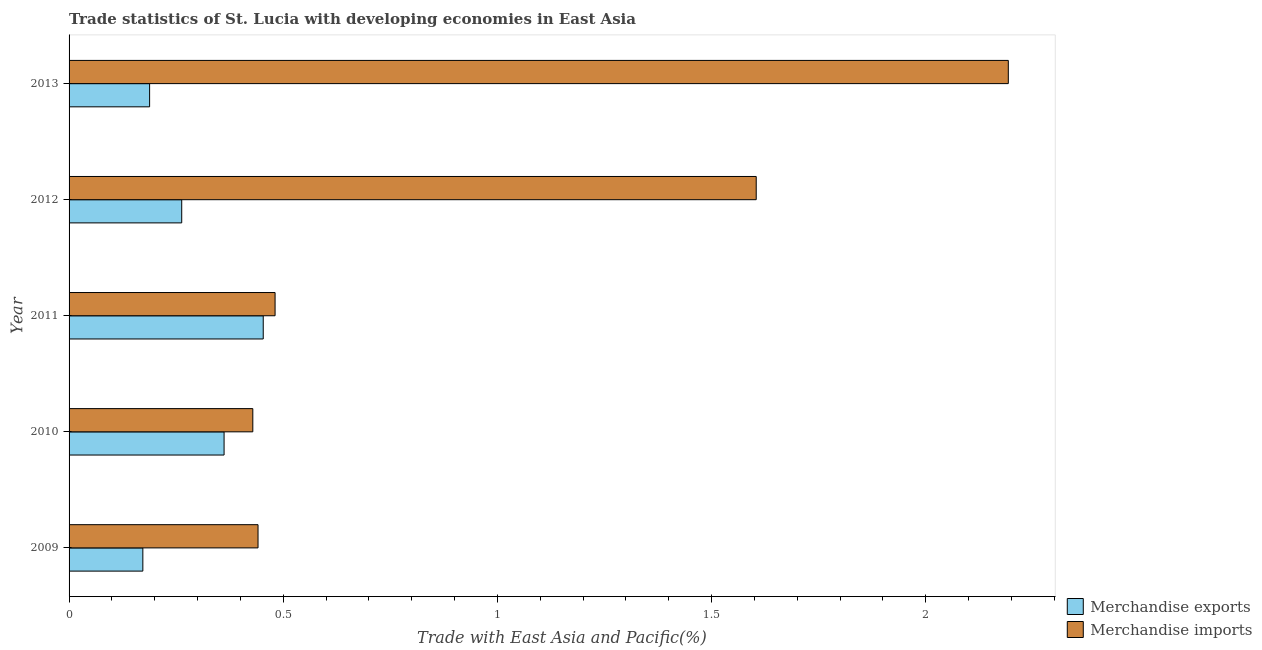How many groups of bars are there?
Give a very brief answer. 5. Are the number of bars per tick equal to the number of legend labels?
Keep it short and to the point. Yes. What is the merchandise imports in 2012?
Give a very brief answer. 1.6. Across all years, what is the maximum merchandise exports?
Offer a very short reply. 0.45. Across all years, what is the minimum merchandise exports?
Your response must be concise. 0.17. What is the total merchandise exports in the graph?
Give a very brief answer. 1.44. What is the difference between the merchandise imports in 2010 and that in 2013?
Your response must be concise. -1.76. What is the difference between the merchandise imports in 2013 and the merchandise exports in 2012?
Your answer should be compact. 1.93. What is the average merchandise imports per year?
Make the answer very short. 1.03. In the year 2009, what is the difference between the merchandise imports and merchandise exports?
Your answer should be compact. 0.27. In how many years, is the merchandise exports greater than 1.9 %?
Make the answer very short. 0. What is the ratio of the merchandise imports in 2010 to that in 2013?
Your answer should be compact. 0.2. Is the merchandise imports in 2012 less than that in 2013?
Provide a short and direct response. Yes. What is the difference between the highest and the second highest merchandise imports?
Your answer should be compact. 0.59. What is the difference between the highest and the lowest merchandise exports?
Your answer should be very brief. 0.28. Is the sum of the merchandise imports in 2010 and 2011 greater than the maximum merchandise exports across all years?
Keep it short and to the point. Yes. What does the 1st bar from the top in 2013 represents?
Ensure brevity in your answer.  Merchandise imports. What does the 2nd bar from the bottom in 2010 represents?
Ensure brevity in your answer.  Merchandise imports. How many bars are there?
Your answer should be very brief. 10. Does the graph contain any zero values?
Offer a very short reply. No. How are the legend labels stacked?
Your answer should be compact. Vertical. What is the title of the graph?
Give a very brief answer. Trade statistics of St. Lucia with developing economies in East Asia. Does "Working capital" appear as one of the legend labels in the graph?
Your answer should be compact. No. What is the label or title of the X-axis?
Your answer should be very brief. Trade with East Asia and Pacific(%). What is the Trade with East Asia and Pacific(%) in Merchandise exports in 2009?
Give a very brief answer. 0.17. What is the Trade with East Asia and Pacific(%) of Merchandise imports in 2009?
Make the answer very short. 0.44. What is the Trade with East Asia and Pacific(%) in Merchandise exports in 2010?
Your answer should be compact. 0.36. What is the Trade with East Asia and Pacific(%) of Merchandise imports in 2010?
Make the answer very short. 0.43. What is the Trade with East Asia and Pacific(%) in Merchandise exports in 2011?
Make the answer very short. 0.45. What is the Trade with East Asia and Pacific(%) of Merchandise imports in 2011?
Your response must be concise. 0.48. What is the Trade with East Asia and Pacific(%) in Merchandise exports in 2012?
Keep it short and to the point. 0.26. What is the Trade with East Asia and Pacific(%) in Merchandise imports in 2012?
Offer a very short reply. 1.6. What is the Trade with East Asia and Pacific(%) of Merchandise exports in 2013?
Offer a very short reply. 0.19. What is the Trade with East Asia and Pacific(%) of Merchandise imports in 2013?
Ensure brevity in your answer.  2.19. Across all years, what is the maximum Trade with East Asia and Pacific(%) in Merchandise exports?
Provide a short and direct response. 0.45. Across all years, what is the maximum Trade with East Asia and Pacific(%) in Merchandise imports?
Your response must be concise. 2.19. Across all years, what is the minimum Trade with East Asia and Pacific(%) in Merchandise exports?
Offer a very short reply. 0.17. Across all years, what is the minimum Trade with East Asia and Pacific(%) of Merchandise imports?
Your answer should be very brief. 0.43. What is the total Trade with East Asia and Pacific(%) in Merchandise exports in the graph?
Provide a short and direct response. 1.44. What is the total Trade with East Asia and Pacific(%) of Merchandise imports in the graph?
Provide a short and direct response. 5.15. What is the difference between the Trade with East Asia and Pacific(%) in Merchandise exports in 2009 and that in 2010?
Your answer should be very brief. -0.19. What is the difference between the Trade with East Asia and Pacific(%) of Merchandise imports in 2009 and that in 2010?
Offer a very short reply. 0.01. What is the difference between the Trade with East Asia and Pacific(%) in Merchandise exports in 2009 and that in 2011?
Your answer should be very brief. -0.28. What is the difference between the Trade with East Asia and Pacific(%) of Merchandise imports in 2009 and that in 2011?
Keep it short and to the point. -0.04. What is the difference between the Trade with East Asia and Pacific(%) in Merchandise exports in 2009 and that in 2012?
Give a very brief answer. -0.09. What is the difference between the Trade with East Asia and Pacific(%) in Merchandise imports in 2009 and that in 2012?
Offer a terse response. -1.16. What is the difference between the Trade with East Asia and Pacific(%) in Merchandise exports in 2009 and that in 2013?
Provide a short and direct response. -0.02. What is the difference between the Trade with East Asia and Pacific(%) in Merchandise imports in 2009 and that in 2013?
Your response must be concise. -1.75. What is the difference between the Trade with East Asia and Pacific(%) in Merchandise exports in 2010 and that in 2011?
Make the answer very short. -0.09. What is the difference between the Trade with East Asia and Pacific(%) of Merchandise imports in 2010 and that in 2011?
Give a very brief answer. -0.05. What is the difference between the Trade with East Asia and Pacific(%) in Merchandise exports in 2010 and that in 2012?
Offer a terse response. 0.1. What is the difference between the Trade with East Asia and Pacific(%) of Merchandise imports in 2010 and that in 2012?
Give a very brief answer. -1.18. What is the difference between the Trade with East Asia and Pacific(%) of Merchandise exports in 2010 and that in 2013?
Give a very brief answer. 0.17. What is the difference between the Trade with East Asia and Pacific(%) of Merchandise imports in 2010 and that in 2013?
Keep it short and to the point. -1.76. What is the difference between the Trade with East Asia and Pacific(%) of Merchandise exports in 2011 and that in 2012?
Your answer should be very brief. 0.19. What is the difference between the Trade with East Asia and Pacific(%) of Merchandise imports in 2011 and that in 2012?
Give a very brief answer. -1.12. What is the difference between the Trade with East Asia and Pacific(%) in Merchandise exports in 2011 and that in 2013?
Give a very brief answer. 0.27. What is the difference between the Trade with East Asia and Pacific(%) of Merchandise imports in 2011 and that in 2013?
Provide a short and direct response. -1.71. What is the difference between the Trade with East Asia and Pacific(%) of Merchandise exports in 2012 and that in 2013?
Your answer should be compact. 0.07. What is the difference between the Trade with East Asia and Pacific(%) of Merchandise imports in 2012 and that in 2013?
Keep it short and to the point. -0.59. What is the difference between the Trade with East Asia and Pacific(%) of Merchandise exports in 2009 and the Trade with East Asia and Pacific(%) of Merchandise imports in 2010?
Offer a terse response. -0.26. What is the difference between the Trade with East Asia and Pacific(%) of Merchandise exports in 2009 and the Trade with East Asia and Pacific(%) of Merchandise imports in 2011?
Offer a terse response. -0.31. What is the difference between the Trade with East Asia and Pacific(%) in Merchandise exports in 2009 and the Trade with East Asia and Pacific(%) in Merchandise imports in 2012?
Provide a succinct answer. -1.43. What is the difference between the Trade with East Asia and Pacific(%) in Merchandise exports in 2009 and the Trade with East Asia and Pacific(%) in Merchandise imports in 2013?
Give a very brief answer. -2.02. What is the difference between the Trade with East Asia and Pacific(%) of Merchandise exports in 2010 and the Trade with East Asia and Pacific(%) of Merchandise imports in 2011?
Your answer should be compact. -0.12. What is the difference between the Trade with East Asia and Pacific(%) in Merchandise exports in 2010 and the Trade with East Asia and Pacific(%) in Merchandise imports in 2012?
Give a very brief answer. -1.24. What is the difference between the Trade with East Asia and Pacific(%) of Merchandise exports in 2010 and the Trade with East Asia and Pacific(%) of Merchandise imports in 2013?
Your answer should be compact. -1.83. What is the difference between the Trade with East Asia and Pacific(%) of Merchandise exports in 2011 and the Trade with East Asia and Pacific(%) of Merchandise imports in 2012?
Offer a very short reply. -1.15. What is the difference between the Trade with East Asia and Pacific(%) of Merchandise exports in 2011 and the Trade with East Asia and Pacific(%) of Merchandise imports in 2013?
Keep it short and to the point. -1.74. What is the difference between the Trade with East Asia and Pacific(%) in Merchandise exports in 2012 and the Trade with East Asia and Pacific(%) in Merchandise imports in 2013?
Offer a terse response. -1.93. What is the average Trade with East Asia and Pacific(%) in Merchandise exports per year?
Provide a short and direct response. 0.29. What is the average Trade with East Asia and Pacific(%) in Merchandise imports per year?
Your answer should be very brief. 1.03. In the year 2009, what is the difference between the Trade with East Asia and Pacific(%) of Merchandise exports and Trade with East Asia and Pacific(%) of Merchandise imports?
Offer a very short reply. -0.27. In the year 2010, what is the difference between the Trade with East Asia and Pacific(%) of Merchandise exports and Trade with East Asia and Pacific(%) of Merchandise imports?
Provide a short and direct response. -0.07. In the year 2011, what is the difference between the Trade with East Asia and Pacific(%) in Merchandise exports and Trade with East Asia and Pacific(%) in Merchandise imports?
Ensure brevity in your answer.  -0.03. In the year 2012, what is the difference between the Trade with East Asia and Pacific(%) of Merchandise exports and Trade with East Asia and Pacific(%) of Merchandise imports?
Ensure brevity in your answer.  -1.34. In the year 2013, what is the difference between the Trade with East Asia and Pacific(%) of Merchandise exports and Trade with East Asia and Pacific(%) of Merchandise imports?
Offer a terse response. -2. What is the ratio of the Trade with East Asia and Pacific(%) in Merchandise exports in 2009 to that in 2010?
Offer a terse response. 0.48. What is the ratio of the Trade with East Asia and Pacific(%) in Merchandise imports in 2009 to that in 2010?
Your answer should be compact. 1.03. What is the ratio of the Trade with East Asia and Pacific(%) in Merchandise exports in 2009 to that in 2011?
Make the answer very short. 0.38. What is the ratio of the Trade with East Asia and Pacific(%) in Merchandise imports in 2009 to that in 2011?
Your answer should be compact. 0.92. What is the ratio of the Trade with East Asia and Pacific(%) of Merchandise exports in 2009 to that in 2012?
Your response must be concise. 0.65. What is the ratio of the Trade with East Asia and Pacific(%) of Merchandise imports in 2009 to that in 2012?
Ensure brevity in your answer.  0.28. What is the ratio of the Trade with East Asia and Pacific(%) in Merchandise exports in 2009 to that in 2013?
Your answer should be compact. 0.92. What is the ratio of the Trade with East Asia and Pacific(%) of Merchandise imports in 2009 to that in 2013?
Ensure brevity in your answer.  0.2. What is the ratio of the Trade with East Asia and Pacific(%) in Merchandise exports in 2010 to that in 2011?
Your answer should be compact. 0.8. What is the ratio of the Trade with East Asia and Pacific(%) in Merchandise imports in 2010 to that in 2011?
Offer a terse response. 0.89. What is the ratio of the Trade with East Asia and Pacific(%) of Merchandise exports in 2010 to that in 2012?
Your answer should be very brief. 1.38. What is the ratio of the Trade with East Asia and Pacific(%) of Merchandise imports in 2010 to that in 2012?
Offer a very short reply. 0.27. What is the ratio of the Trade with East Asia and Pacific(%) in Merchandise exports in 2010 to that in 2013?
Offer a terse response. 1.92. What is the ratio of the Trade with East Asia and Pacific(%) in Merchandise imports in 2010 to that in 2013?
Provide a succinct answer. 0.2. What is the ratio of the Trade with East Asia and Pacific(%) of Merchandise exports in 2011 to that in 2012?
Offer a terse response. 1.72. What is the ratio of the Trade with East Asia and Pacific(%) of Merchandise imports in 2011 to that in 2012?
Your answer should be compact. 0.3. What is the ratio of the Trade with East Asia and Pacific(%) of Merchandise exports in 2011 to that in 2013?
Offer a terse response. 2.41. What is the ratio of the Trade with East Asia and Pacific(%) of Merchandise imports in 2011 to that in 2013?
Your response must be concise. 0.22. What is the ratio of the Trade with East Asia and Pacific(%) of Merchandise exports in 2012 to that in 2013?
Provide a short and direct response. 1.4. What is the ratio of the Trade with East Asia and Pacific(%) of Merchandise imports in 2012 to that in 2013?
Make the answer very short. 0.73. What is the difference between the highest and the second highest Trade with East Asia and Pacific(%) of Merchandise exports?
Offer a very short reply. 0.09. What is the difference between the highest and the second highest Trade with East Asia and Pacific(%) of Merchandise imports?
Keep it short and to the point. 0.59. What is the difference between the highest and the lowest Trade with East Asia and Pacific(%) in Merchandise exports?
Provide a succinct answer. 0.28. What is the difference between the highest and the lowest Trade with East Asia and Pacific(%) in Merchandise imports?
Give a very brief answer. 1.76. 